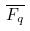<formula> <loc_0><loc_0><loc_500><loc_500>\overline { F _ { q } }</formula> 